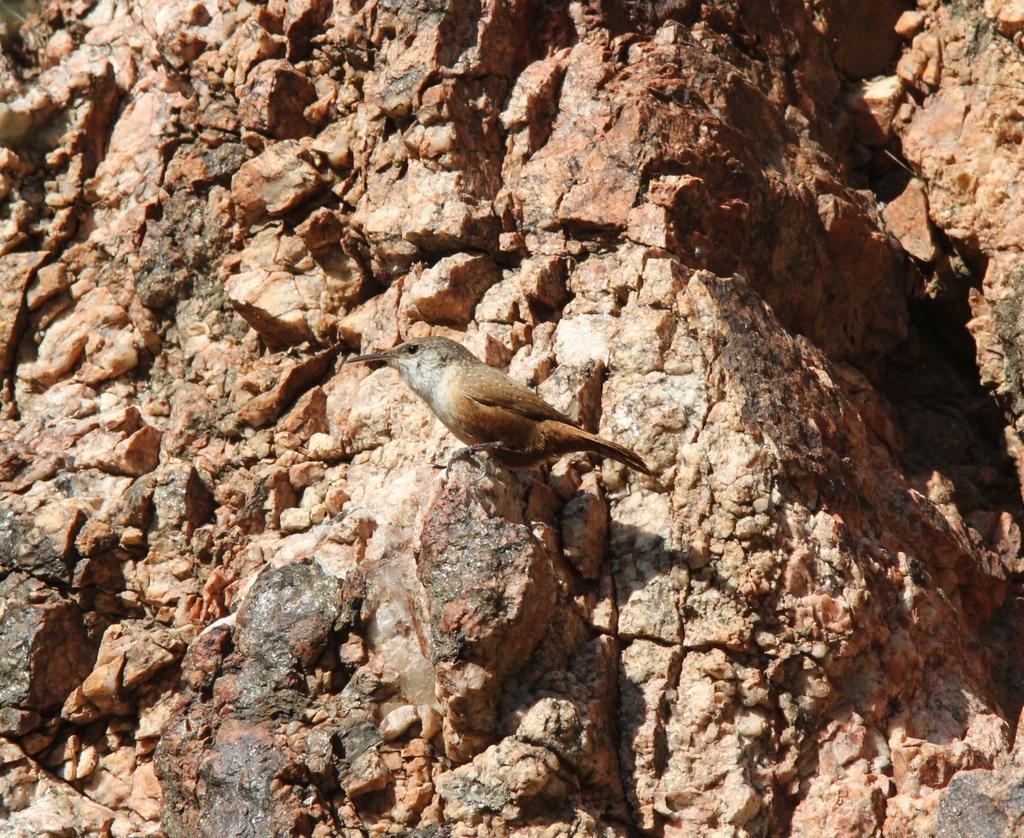Can you describe this image briefly? In this picture we can see bird and rock. 